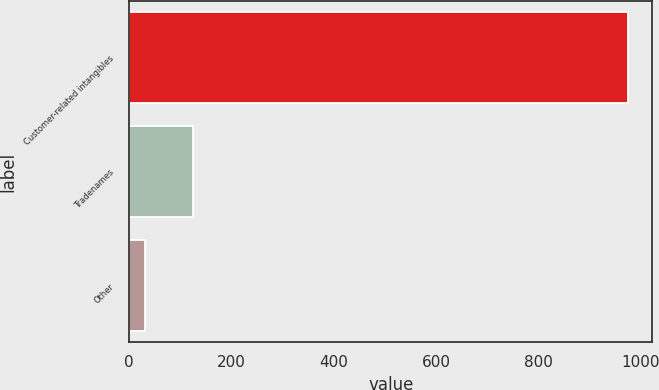Convert chart to OTSL. <chart><loc_0><loc_0><loc_500><loc_500><bar_chart><fcel>Customer-related intangibles<fcel>Tradenames<fcel>Other<nl><fcel>974<fcel>125.3<fcel>31<nl></chart> 